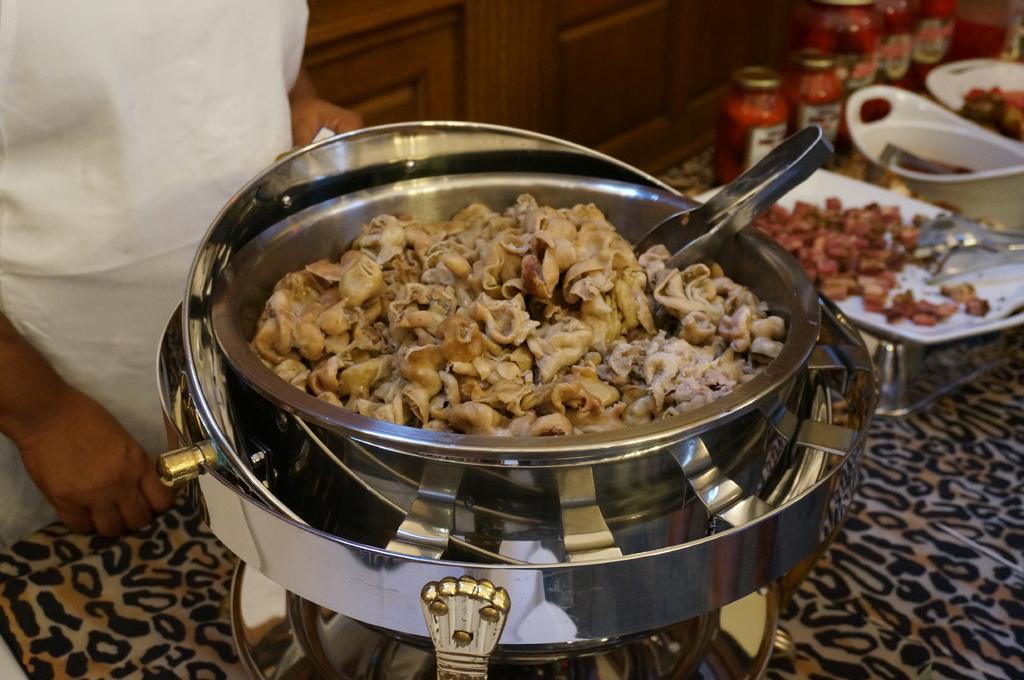Please provide a concise description of this image. In this image we can see a person standing on the floor, pet jars, serving plates which consists of food and tongs in them. 